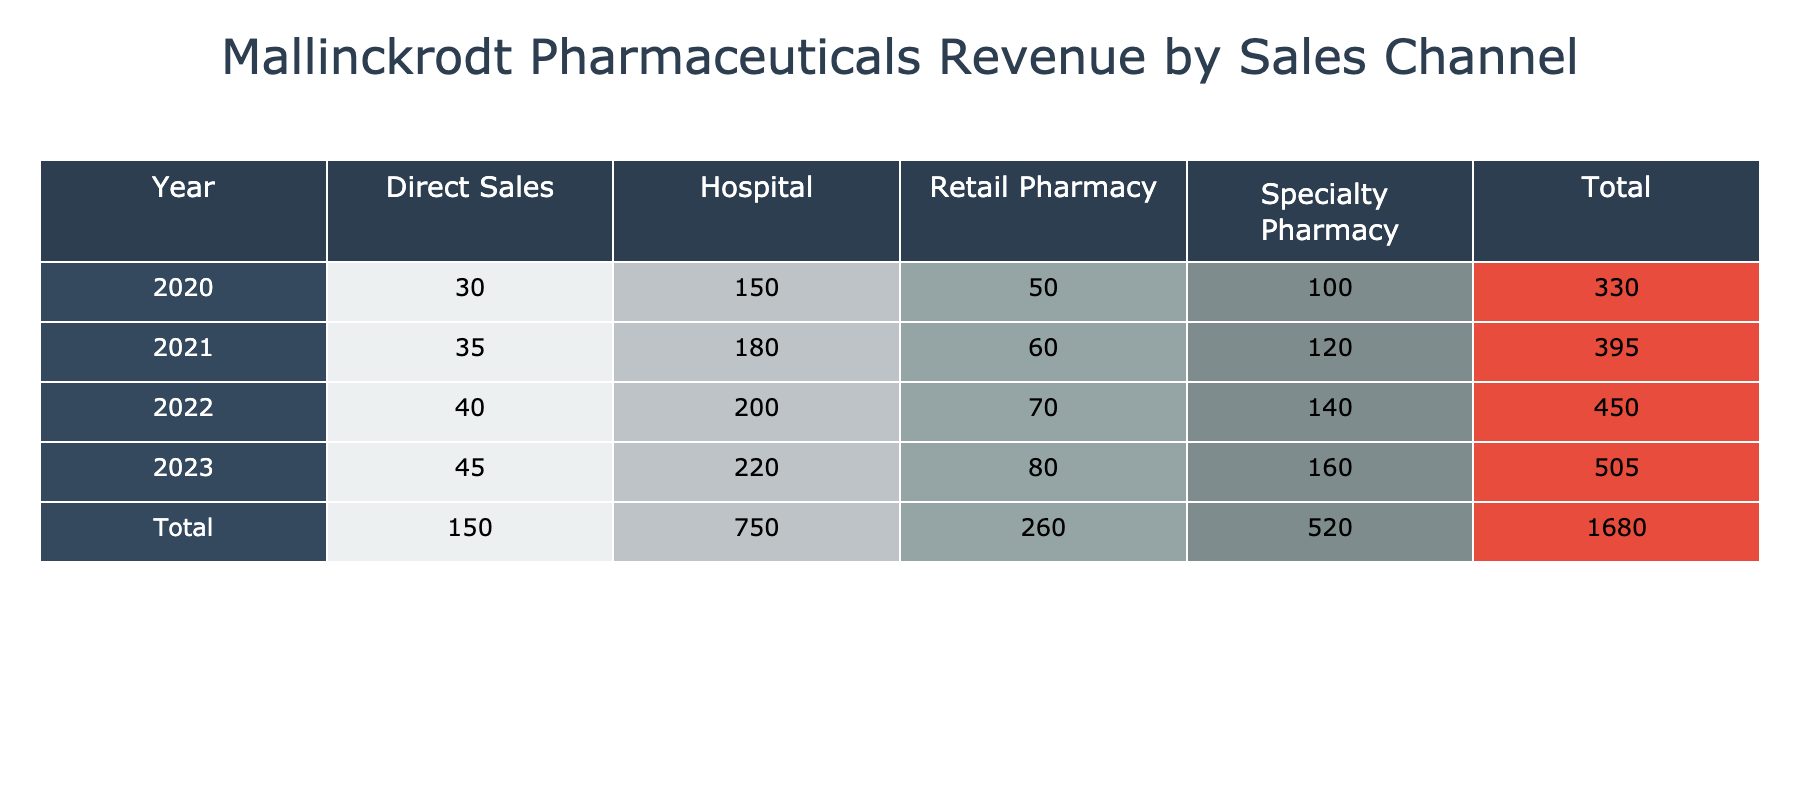What was the total revenue from the Retail Pharmacy channel in 2022? To find the total revenue from the Retail Pharmacy channel for 2022, we look at the revenue figure corresponding to that year and channel in the table. The value for Retail Pharmacy in 2022 is 70 million.
Answer: 70 million What is the percentage increase in revenue from the Direct Sales channel from 2020 to 2023? First, we find the revenue for Direct Sales in 2020 (30 million) and in 2023 (45 million). The difference is 45 - 30 = 15 million. To find the percentage increase, we calculate (15 / 30) * 100 = 50%.
Answer: 50% Did the revenue from the Specialty Pharmacy channel increase every year from 2020 to 2023? By examining the table, we see the revenues for Specialty Pharmacy: 100 million in 2020, 120 million in 2021, 140 million in 2022, and finally 160 million in 2023. Since each year's revenue is higher than the previous year, the answer is yes.
Answer: Yes What was the total revenue generated by hospitals from 2020 to 2023? We need to find the revenue for hospitals for each year and sum them up: 150 million (2020) + 180 million (2021) + 200 million (2022) + 220 million (2023) = 150 + 180 + 200 + 220 = 750 million.
Answer: 750 million Which sales channel generated the highest revenue in 2021? Looking at the table for 2021, we see the revenue figures: Hospital (180 million), Specialty Pharmacy (120 million), Retail Pharmacy (60 million), and Direct Sales (35 million). The highest revenue is from the Hospital channel at 180 million.
Answer: Hospital What was the average revenue across all channels in 2020? For 2020, the revenues for each channel are: Hospital (150 million), Specialty Pharmacy (100 million), Retail Pharmacy (50 million), and Direct Sales (30 million). First, we sum these to find total revenue: 150 + 100 + 50 + 30 = 330 million. There are four channels, so the average revenue is 330 / 4 = 82.5 million.
Answer: 82.5 million In which year did the Specialty Pharmacy channel experience its highest revenue? By checking the table for the Specialty Pharmacy channel's revenue across the years, we find: 100 million (2020), 120 million (2021), 140 million (2022), and 160 million (2023). The highest revenue for this channel occurred in 2023.
Answer: 2023 Is the total revenue from all sales channels in 2023 greater than that in 2020? First, we calculate the total revenue for 2023: Hospital (220 million) + Specialty Pharmacy (160 million) + Retail Pharmacy (80 million) + Direct Sales (45 million) = 220 + 160 + 80 + 45 = 505 million. The total for 2020 is 330 million. Since 505 million is greater than 330 million, the answer is yes.
Answer: Yes 